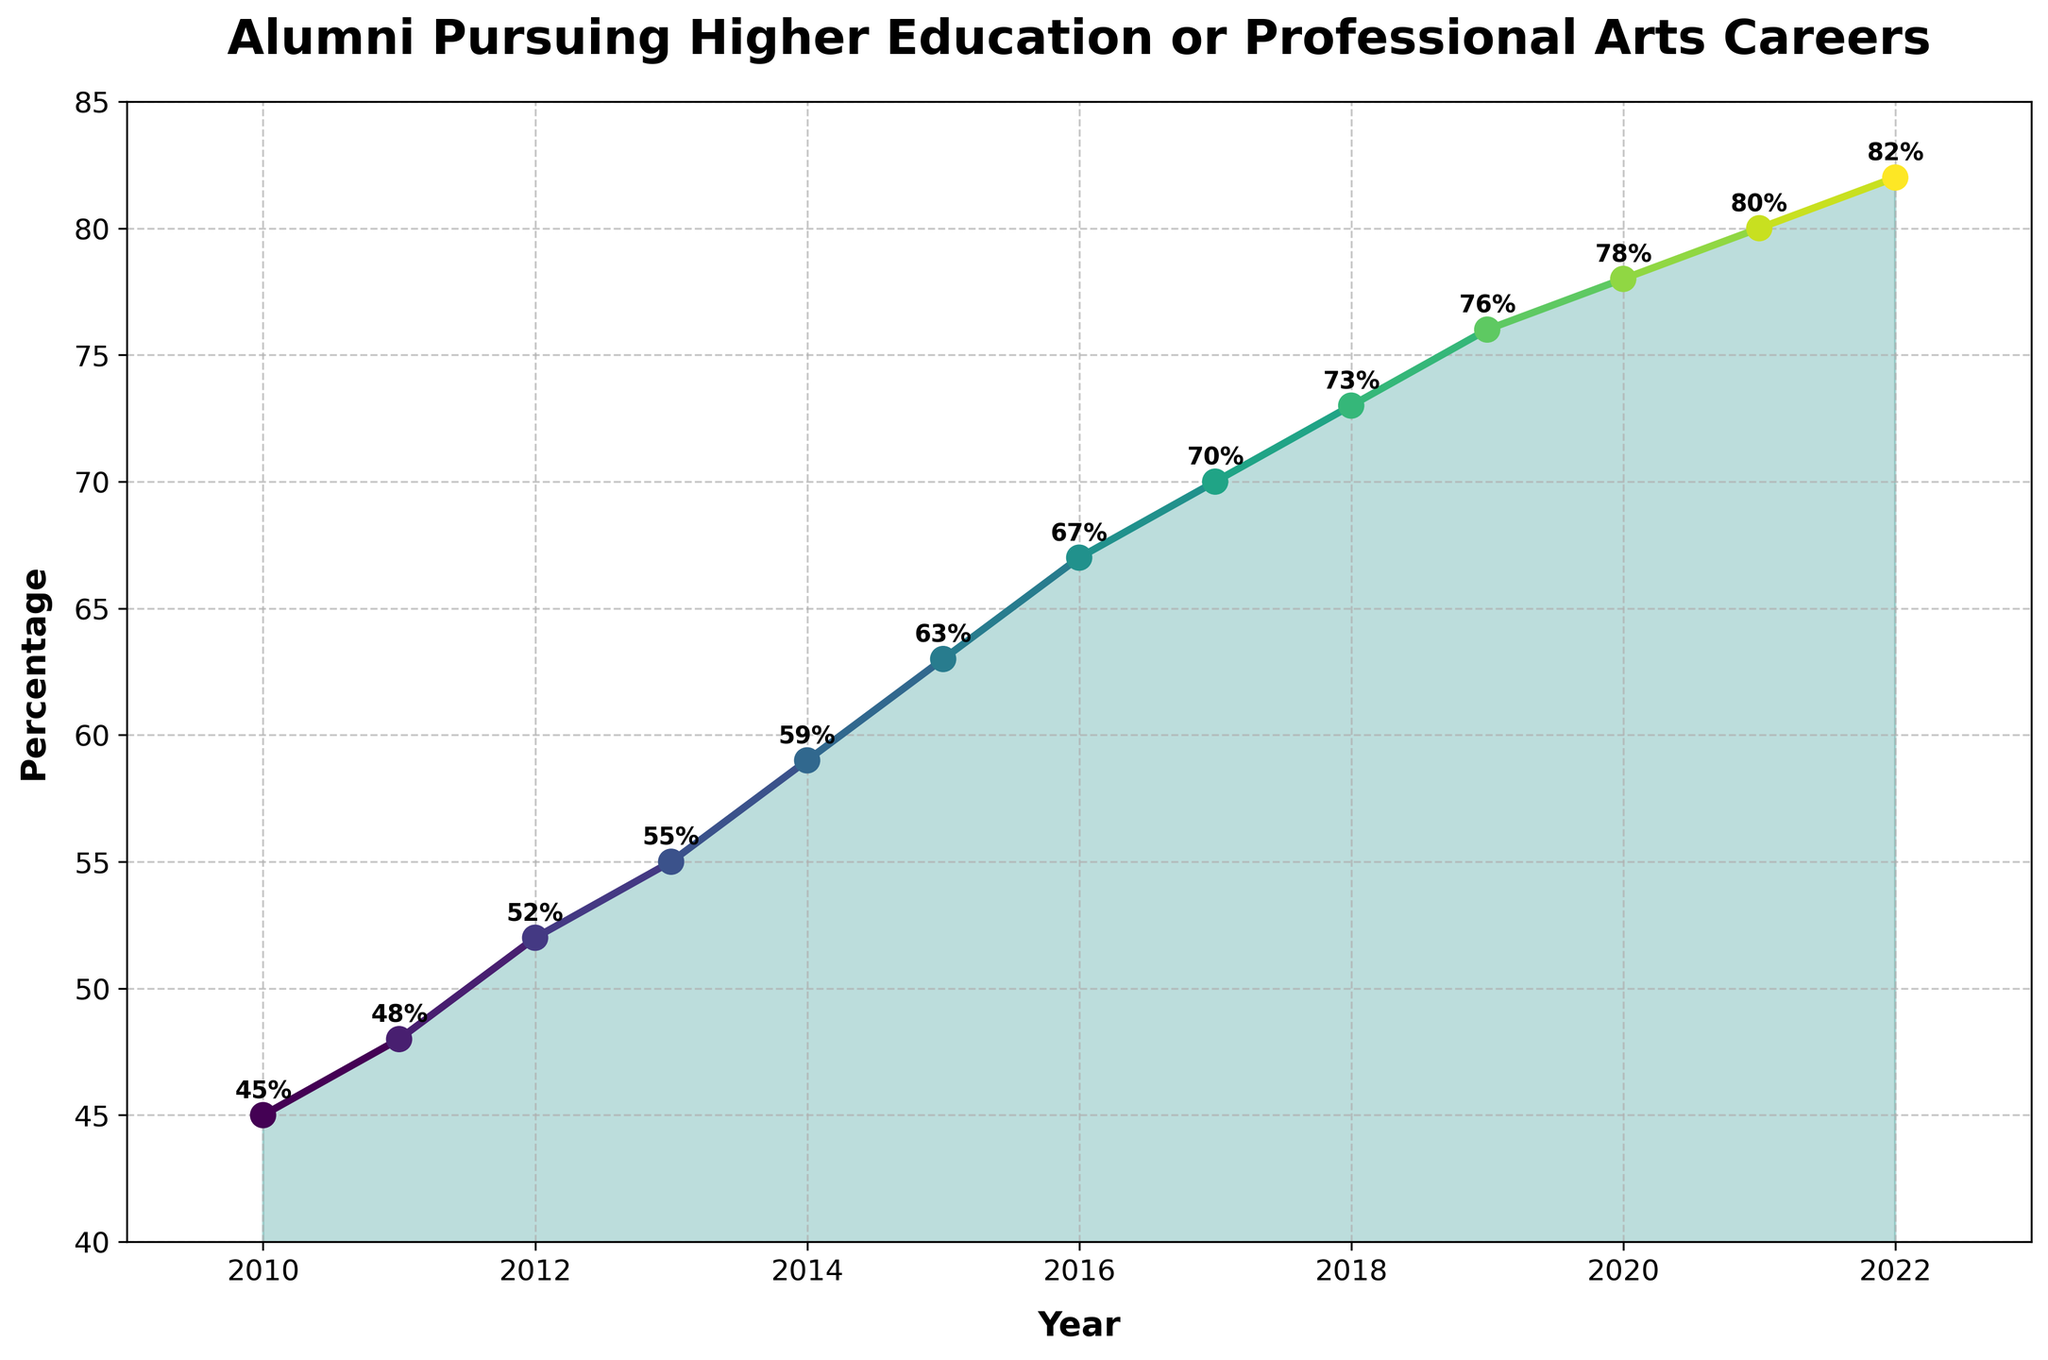What is the overall trend observed in the percentage of alumni pursuing higher education or professional arts careers from 2010 to 2022? The overall trend shows a steady increase in the percentage of alumni pursuing higher education or professional arts careers year by year from 2010 to 2022.
Answer: Steady increase By how many percentage points did the percentage of alumni pursuing higher education or professional arts careers increase from 2010 to 2022? To find the increase, subtract the percentage in 2010 from the percentage in 2022 (82 - 45).
Answer: 37 percentage points Between which two consecutive years was the largest increase in the percentage of alumni pursuing higher education or professional arts careers observed? Observing the yearly increments: 2010-2011: 3, 2011-2012: 4, 2012-2013: 3, 2013-2014: 4, 2014-2015: 4, 2015-2016: 4, 2016-2017: 3, 2017-2018: 3, 2018-2019: 3, 2019-2020: 2, 2020-2021: 2, 2021-2022: 2. The largest increase of 4 percentage points occurred between several pairs of consecutive years, specifically 2011-2012, 2013-2014, 2014-2015, 2015-2016.
Answer: 2011–2012, 2013–2014, 2014–2015, and 2015–2016 Calculate the average annual increase in the percentage of alumni pursuing higher education or professional arts careers from 2010 to 2022. First, find the total increase over 12 years: 82 - 45 = 37. Then, divide by the number of years (12).
Answer: 3.08 percentage points In which year did the percentage of alumni pursuing higher education or professional arts careers first exceed 60%? The percentage first exceeded 60% in 2015, reaching 63%.
Answer: 2015 Which year had the smallest percentage increase compared to the previous year? By comparing the yearly increments: 2010-2011: 3, 2011-2012: 4, 2012-2013: 3, 2013-2014: 4, 2014-2015: 4, 2015-2016: 4, 2016-2017: 3, 2017-2018: 3, 2018-2019: 3, 2019-2020: 2, 2020-2021: 2, 2021-2022: 2. The smallest increase of 2 percentage points occurred between 2019-2020, 2020-2021, and 2021-2022.
Answer: 2019-2020, 2020-2021, and 2021-2022 By what percentage did the number of alumni pursuing higher education or professional arts careers increase between 2014 and 2018? Subtract the percentage in 2014 from the percentage in 2018 (73 - 59).
Answer: 14 percentage points 